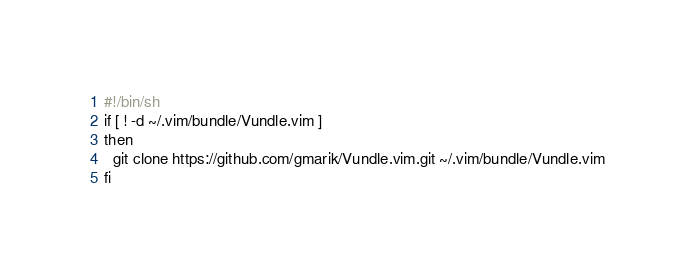Convert code to text. <code><loc_0><loc_0><loc_500><loc_500><_Bash_>#!/bin/sh
if [ ! -d ~/.vim/bundle/Vundle.vim ]
then
  git clone https://github.com/gmarik/Vundle.vim.git ~/.vim/bundle/Vundle.vim
fi
</code> 